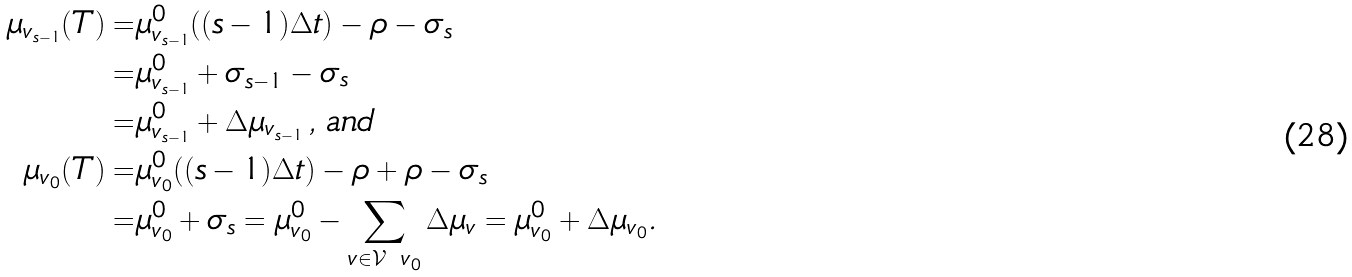Convert formula to latex. <formula><loc_0><loc_0><loc_500><loc_500>\mu _ { v _ { s - 1 } } ( T ) = & \mu ^ { 0 } _ { v _ { s - 1 } } ( ( s - 1 ) \Delta t ) - \rho - \sigma _ { s } \\ = & \mu ^ { 0 } _ { v _ { s - 1 } } + \sigma _ { s - 1 } - \sigma _ { s } \\ = & \mu ^ { 0 } _ { v _ { s - 1 } } + \Delta \mu _ { v _ { s - 1 } } \, , \, a n d \, \\ \mu _ { v _ { 0 } } ( T ) = & \mu ^ { 0 } _ { v _ { 0 } } ( ( { s - 1 } ) \Delta t ) - \rho + \rho - \sigma _ { s } \\ = & \mu ^ { 0 } _ { v _ { 0 } } + \sigma _ { s } = \mu ^ { 0 } _ { v _ { 0 } } - \sum _ { v \in \mathcal { V } \ v _ { 0 } } \Delta \mu _ { v } = \mu ^ { 0 } _ { v _ { 0 } } + \Delta \mu _ { v _ { 0 } } .</formula> 